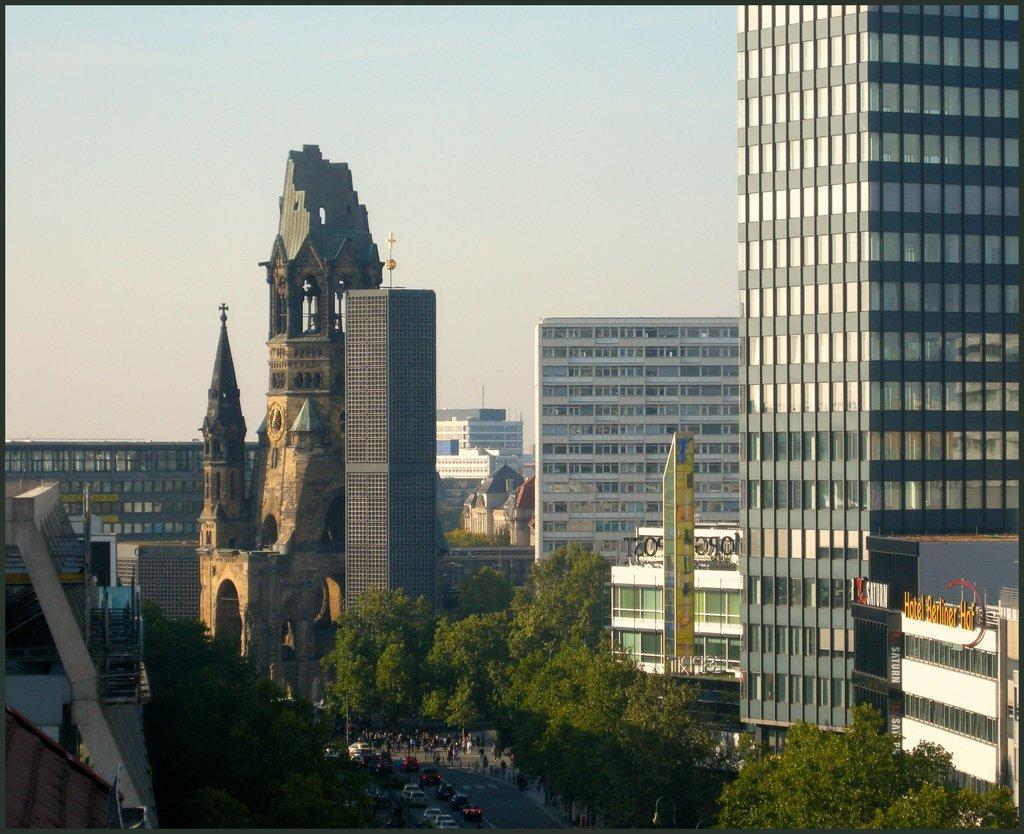Can you describe this image briefly? This picture shows few buildings and we see trees and few cars moving on the road. 